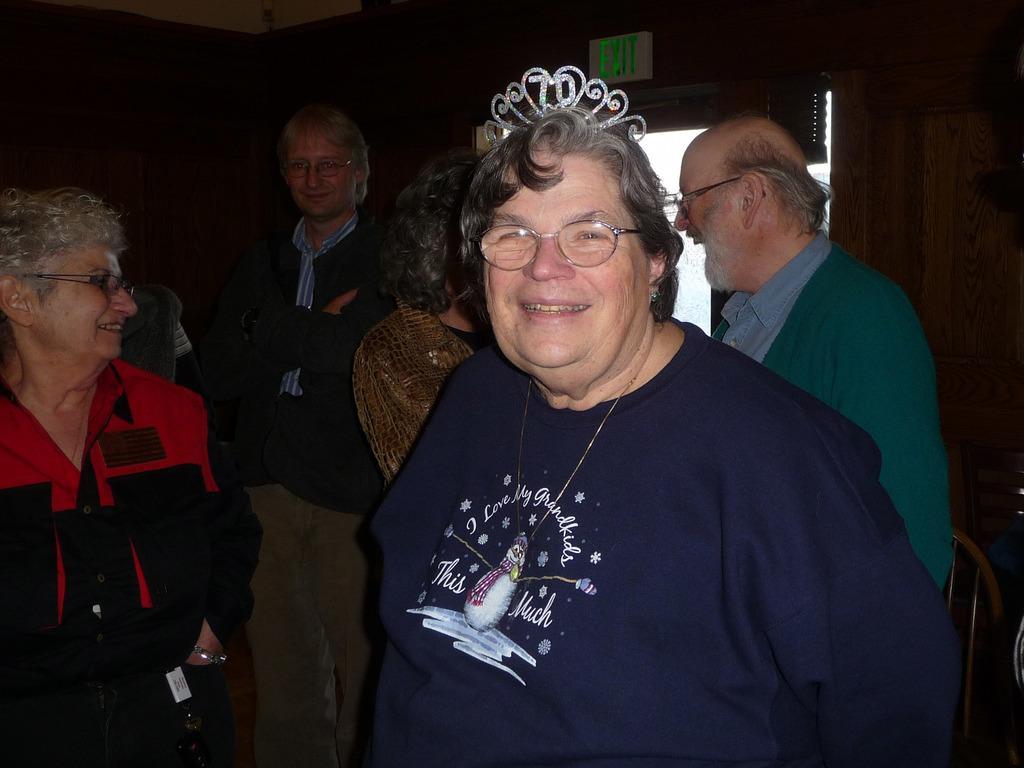In one or two sentences, can you explain what this image depicts? In this picture we can see some people standing, a person in the front wore spectacles, on the right side there is an exit board, we can see a dark background. 